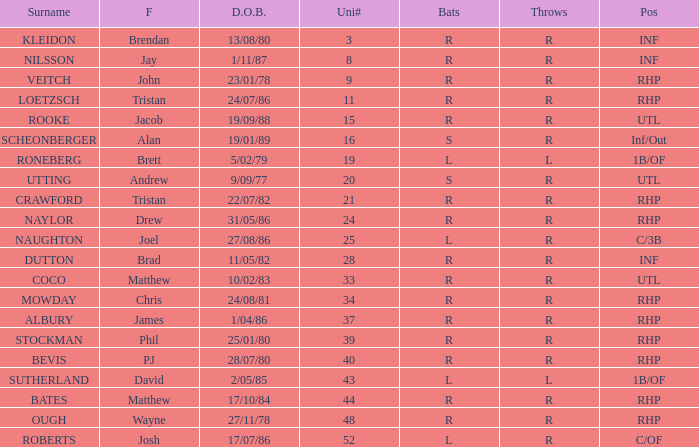Which Surname has Throws of l, and a DOB of 5/02/79? RONEBERG. 